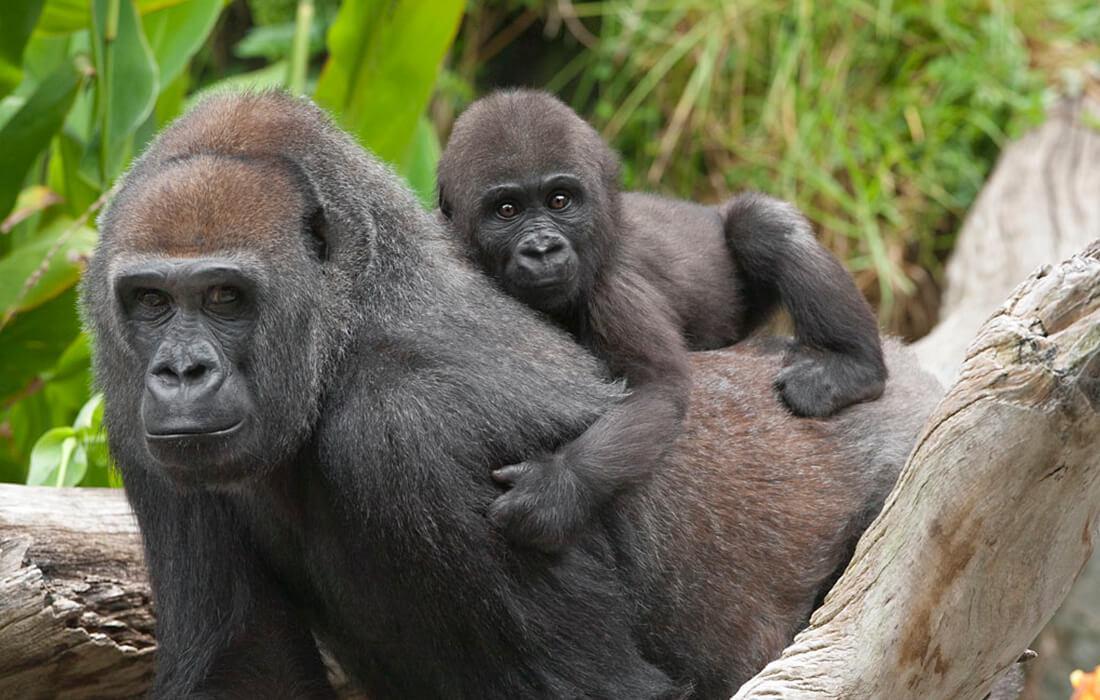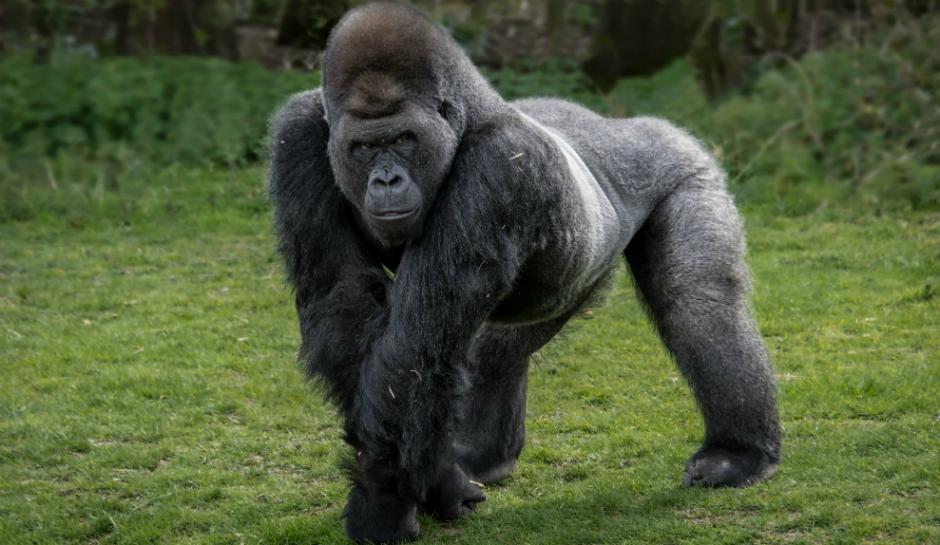The first image is the image on the left, the second image is the image on the right. For the images displayed, is the sentence "One of the images features a lone male." factually correct? Answer yes or no. Yes. The first image is the image on the left, the second image is the image on the right. Given the left and right images, does the statement "One gorilla is carrying a baby gorilla on its back." hold true? Answer yes or no. Yes. 